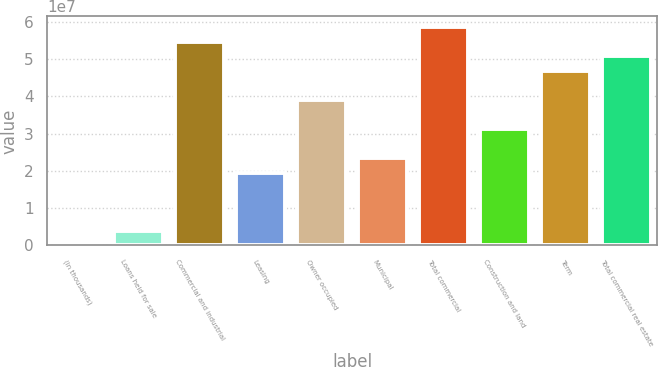<chart> <loc_0><loc_0><loc_500><loc_500><bar_chart><fcel>(In thousands)<fcel>Loans held for sale<fcel>Commercial and industrial<fcel>Leasing<fcel>Owner occupied<fcel>Municipal<fcel>Total commercial<fcel>Construction and land<fcel>Term<fcel>Total commercial real estate<nl><fcel>2013<fcel>3.90615e+06<fcel>5.46599e+07<fcel>1.95227e+07<fcel>3.90434e+07<fcel>2.34268e+07<fcel>5.8564e+07<fcel>3.12351e+07<fcel>4.68516e+07<fcel>5.07558e+07<nl></chart> 